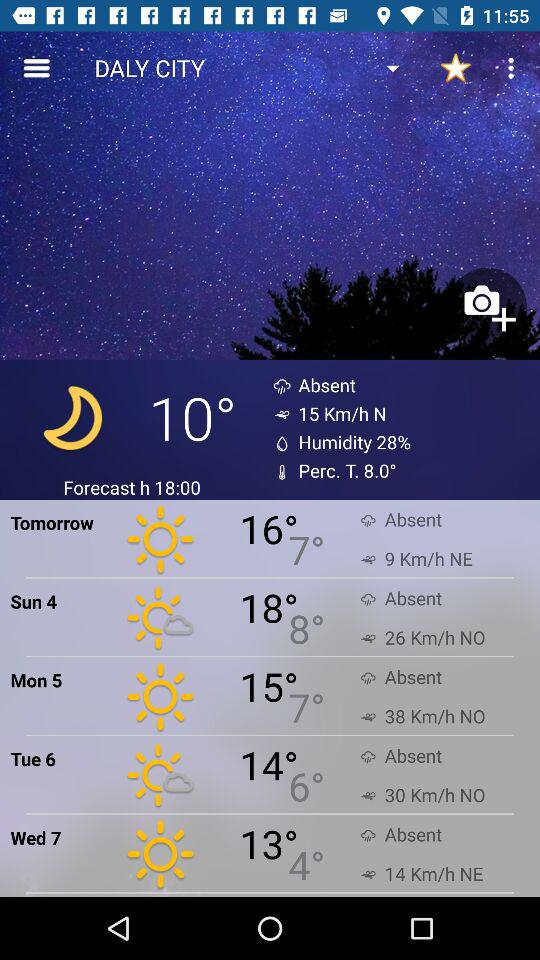How many days in the forecast have a wind speed of 30 Km/h or more?
Answer the question using a single word or phrase. 2 